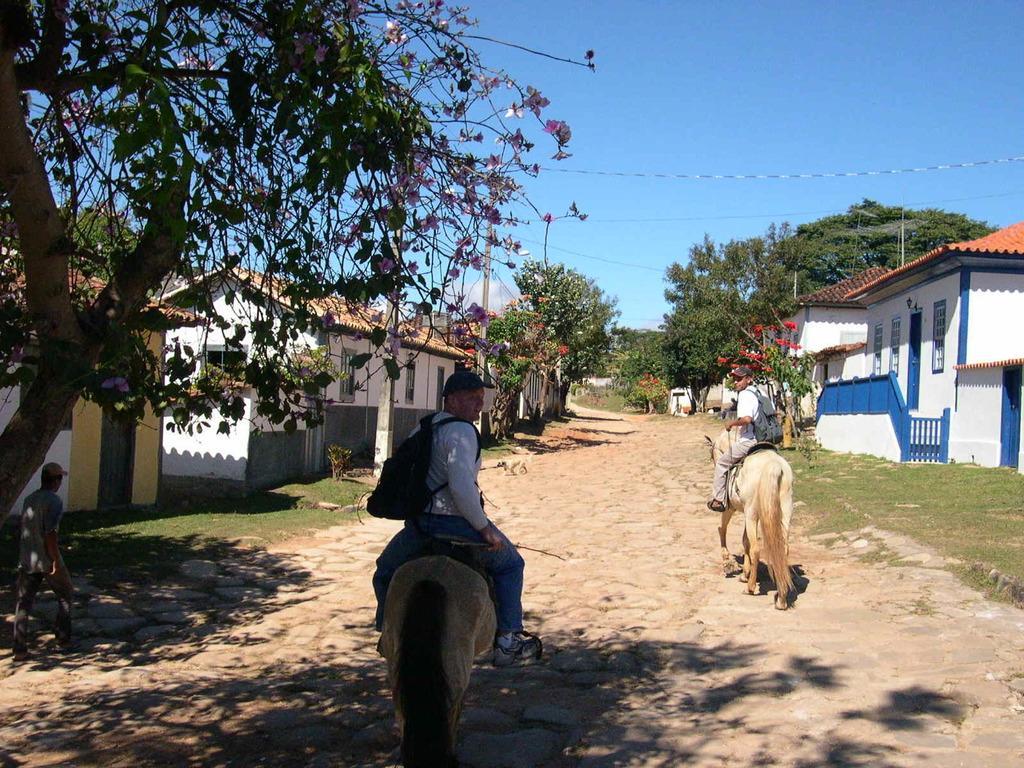Describe this image in one or two sentences. In this picture there are two men who are riding on a horses. They both have a backpack. To the left there is a man who is walking on the path. There is a tree and a house. Sky is blue. 